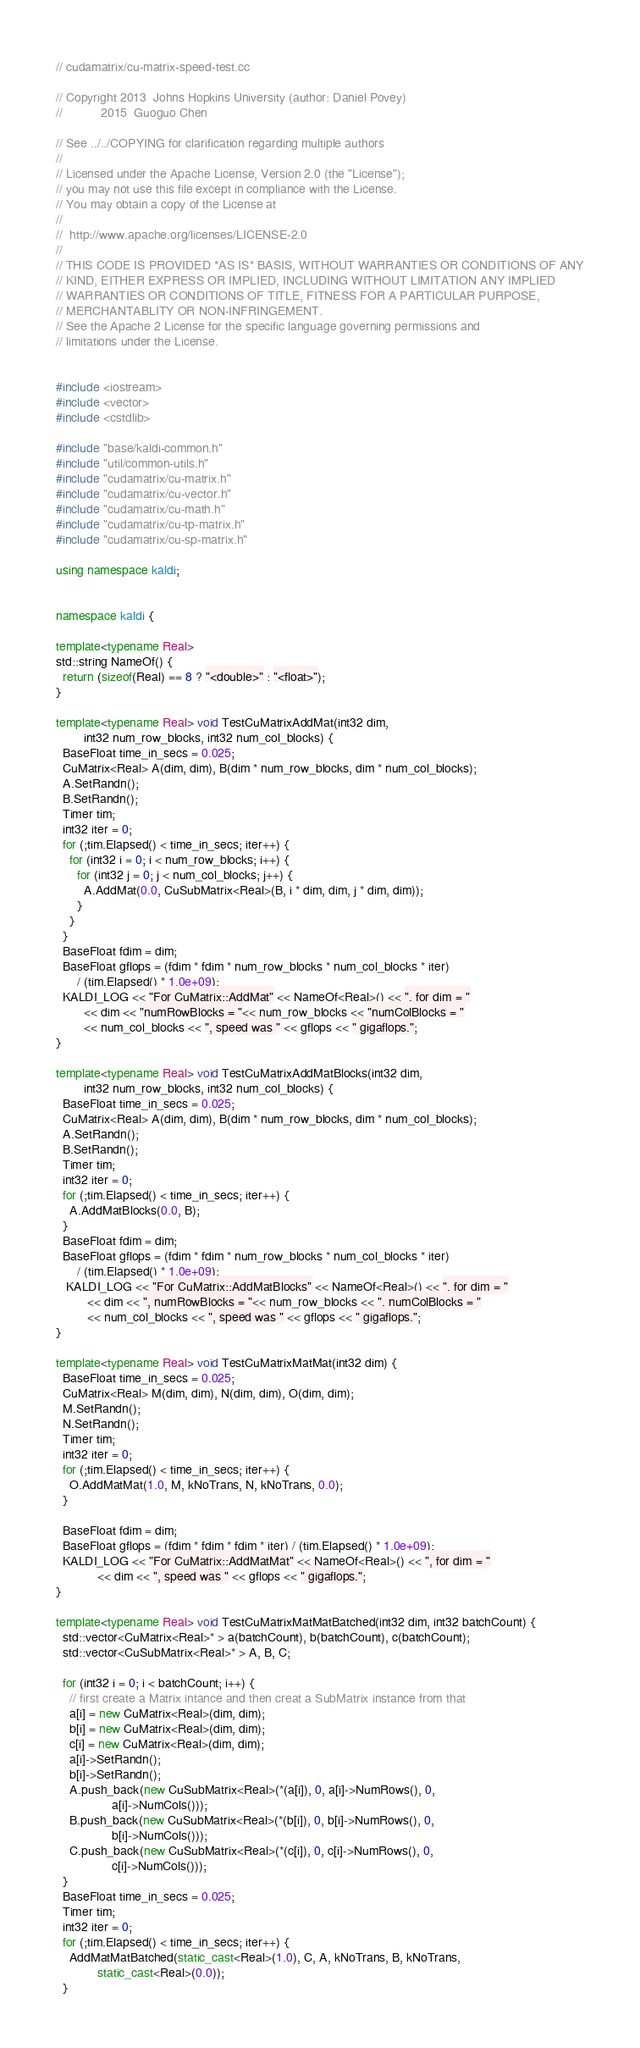<code> <loc_0><loc_0><loc_500><loc_500><_C++_>// cudamatrix/cu-matrix-speed-test.cc

// Copyright 2013  Johns Hopkins University (author: Daniel Povey)
//           2015  Guoguo Chen

// See ../../COPYING for clarification regarding multiple authors
//
// Licensed under the Apache License, Version 2.0 (the "License");
// you may not use this file except in compliance with the License.
// You may obtain a copy of the License at
//
//  http://www.apache.org/licenses/LICENSE-2.0
//
// THIS CODE IS PROVIDED *AS IS* BASIS, WITHOUT WARRANTIES OR CONDITIONS OF ANY
// KIND, EITHER EXPRESS OR IMPLIED, INCLUDING WITHOUT LIMITATION ANY IMPLIED
// WARRANTIES OR CONDITIONS OF TITLE, FITNESS FOR A PARTICULAR PURPOSE,
// MERCHANTABLITY OR NON-INFRINGEMENT.
// See the Apache 2 License for the specific language governing permissions and
// limitations under the License.


#include <iostream>
#include <vector>
#include <cstdlib>

#include "base/kaldi-common.h"
#include "util/common-utils.h"
#include "cudamatrix/cu-matrix.h"
#include "cudamatrix/cu-vector.h"
#include "cudamatrix/cu-math.h"
#include "cudamatrix/cu-tp-matrix.h"
#include "cudamatrix/cu-sp-matrix.h"

using namespace kaldi;


namespace kaldi {

template<typename Real>
std::string NameOf() {
  return (sizeof(Real) == 8 ? "<double>" : "<float>");
}

template<typename Real> void TestCuMatrixAddMat(int32 dim, 
		int32 num_row_blocks, int32 num_col_blocks) {
  BaseFloat time_in_secs = 0.025;
  CuMatrix<Real> A(dim, dim), B(dim * num_row_blocks, dim * num_col_blocks);
  A.SetRandn();
  B.SetRandn();
  Timer tim;
  int32 iter = 0;
  for (;tim.Elapsed() < time_in_secs; iter++) {
    for (int32 i = 0; i < num_row_blocks; i++) {
      for (int32 j = 0; j < num_col_blocks; j++) {
        A.AddMat(0.0, CuSubMatrix<Real>(B, i * dim, dim, j * dim, dim));
      }
    }
  }
  BaseFloat fdim = dim;
  BaseFloat gflops = (fdim * fdim * num_row_blocks * num_col_blocks * iter) 
	  / (tim.Elapsed() * 1.0e+09);
  KALDI_LOG << "For CuMatrix::AddMat" << NameOf<Real>() << ", for dim = "
	    << dim << "numRowBlocks = "<< num_row_blocks << "numColBlocks = "
	    << num_col_blocks << ", speed was " << gflops << " gigaflops.";
}

template<typename Real> void TestCuMatrixAddMatBlocks(int32 dim, 
		int32 num_row_blocks, int32 num_col_blocks) {
  BaseFloat time_in_secs = 0.025;
  CuMatrix<Real> A(dim, dim), B(dim * num_row_blocks, dim * num_col_blocks);
  A.SetRandn();
  B.SetRandn();
  Timer tim;
  int32 iter = 0;
  for (;tim.Elapsed() < time_in_secs; iter++) {
    A.AddMatBlocks(0.0, B);
  }
  BaseFloat fdim = dim;
  BaseFloat gflops = (fdim * fdim * num_row_blocks * num_col_blocks * iter) 
	  / (tim.Elapsed() * 1.0e+09);
   KALDI_LOG << "For CuMatrix::AddMatBlocks" << NameOf<Real>() << ", for dim = "
	     << dim << ", numRowBlocks = "<< num_row_blocks << ", numColBlocks = "
	     << num_col_blocks << ", speed was " << gflops << " gigaflops.";
}

template<typename Real> void TestCuMatrixMatMat(int32 dim) {
  BaseFloat time_in_secs = 0.025;
  CuMatrix<Real> M(dim, dim), N(dim, dim), O(dim, dim);
  M.SetRandn();
  N.SetRandn();
  Timer tim;
  int32 iter = 0;
  for (;tim.Elapsed() < time_in_secs; iter++) {
    O.AddMatMat(1.0, M, kNoTrans, N, kNoTrans, 0.0);
  }

  BaseFloat fdim = dim;
  BaseFloat gflops = (fdim * fdim * fdim * iter) / (tim.Elapsed() * 1.0e+09);
  KALDI_LOG << "For CuMatrix::AddMatMat" << NameOf<Real>() << ", for dim = "
            << dim << ", speed was " << gflops << " gigaflops.";
}

template<typename Real> void TestCuMatrixMatMatBatched(int32 dim, int32 batchCount) {
  std::vector<CuMatrix<Real>* > a(batchCount), b(batchCount), c(batchCount);
  std::vector<CuSubMatrix<Real>* > A, B, C;
  
  for (int32 i = 0; i < batchCount; i++) {
    // first create a Matrix intance and then creat a SubMatrix instance from that
    a[i] = new CuMatrix<Real>(dim, dim);
    b[i] = new CuMatrix<Real>(dim, dim);
    c[i] = new CuMatrix<Real>(dim, dim);
    a[i]->SetRandn();
    b[i]->SetRandn();
    A.push_back(new CuSubMatrix<Real>(*(a[i]), 0, a[i]->NumRows(), 0, 
			    a[i]->NumCols()));
    B.push_back(new CuSubMatrix<Real>(*(b[i]), 0, b[i]->NumRows(), 0, 
			    b[i]->NumCols()));
    C.push_back(new CuSubMatrix<Real>(*(c[i]), 0, c[i]->NumRows(), 0, 
			    c[i]->NumCols()));
  }
  BaseFloat time_in_secs = 0.025;
  Timer tim;
  int32 iter = 0;
  for (;tim.Elapsed() < time_in_secs; iter++) {
    AddMatMatBatched(static_cast<Real>(1.0), C, A, kNoTrans, B, kNoTrans, 
		    static_cast<Real>(0.0));
  }</code> 